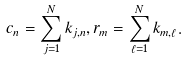<formula> <loc_0><loc_0><loc_500><loc_500>c _ { n } = \sum _ { j = 1 } ^ { N } k _ { j , n } , r _ { m } = \sum _ { \ell = 1 } ^ { N } k _ { m , \ell } .</formula> 